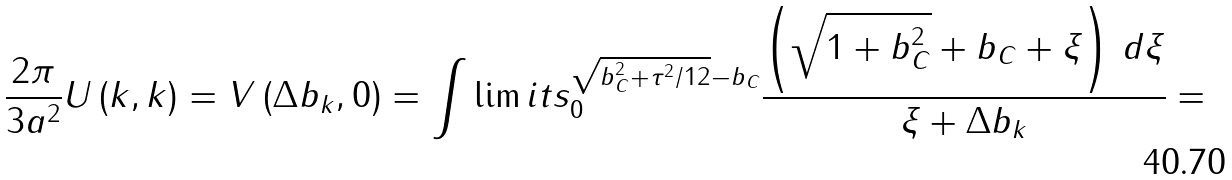Convert formula to latex. <formula><loc_0><loc_0><loc_500><loc_500>\frac { 2 \pi } { { 3 a ^ { 2 } } } U \left ( { k , k } \right ) = V \left ( { \Delta b _ { k } , 0 } \right ) = \int \lim i t s _ { 0 } ^ { \sqrt { b _ { C } ^ { 2 } + \tau ^ { 2 } / 1 2 } - b _ { C } } { \frac { { \left ( { \sqrt { 1 + b _ { C } ^ { 2 } } + b _ { C } + \xi } \right ) \, d \xi } } { { \xi + \Delta b _ { k } } } } =</formula> 